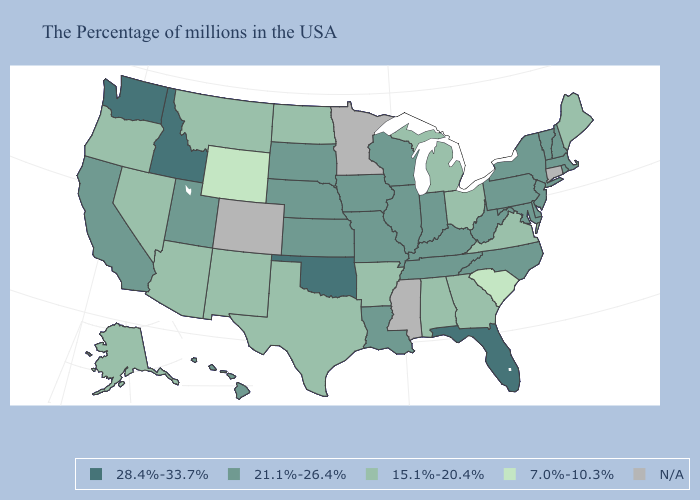What is the value of Michigan?
Keep it brief. 15.1%-20.4%. Name the states that have a value in the range N/A?
Keep it brief. Connecticut, Mississippi, Minnesota, Colorado. What is the highest value in the South ?
Keep it brief. 28.4%-33.7%. Does the first symbol in the legend represent the smallest category?
Short answer required. No. Name the states that have a value in the range 15.1%-20.4%?
Keep it brief. Maine, Virginia, Ohio, Georgia, Michigan, Alabama, Arkansas, Texas, North Dakota, New Mexico, Montana, Arizona, Nevada, Oregon, Alaska. What is the highest value in states that border South Dakota?
Be succinct. 21.1%-26.4%. What is the lowest value in the USA?
Write a very short answer. 7.0%-10.3%. What is the value of Colorado?
Keep it brief. N/A. How many symbols are there in the legend?
Answer briefly. 5. What is the value of Rhode Island?
Be succinct. 21.1%-26.4%. What is the value of Massachusetts?
Give a very brief answer. 21.1%-26.4%. Name the states that have a value in the range N/A?
Short answer required. Connecticut, Mississippi, Minnesota, Colorado. Name the states that have a value in the range 28.4%-33.7%?
Write a very short answer. Florida, Oklahoma, Idaho, Washington. Does Wyoming have the highest value in the West?
Write a very short answer. No. 